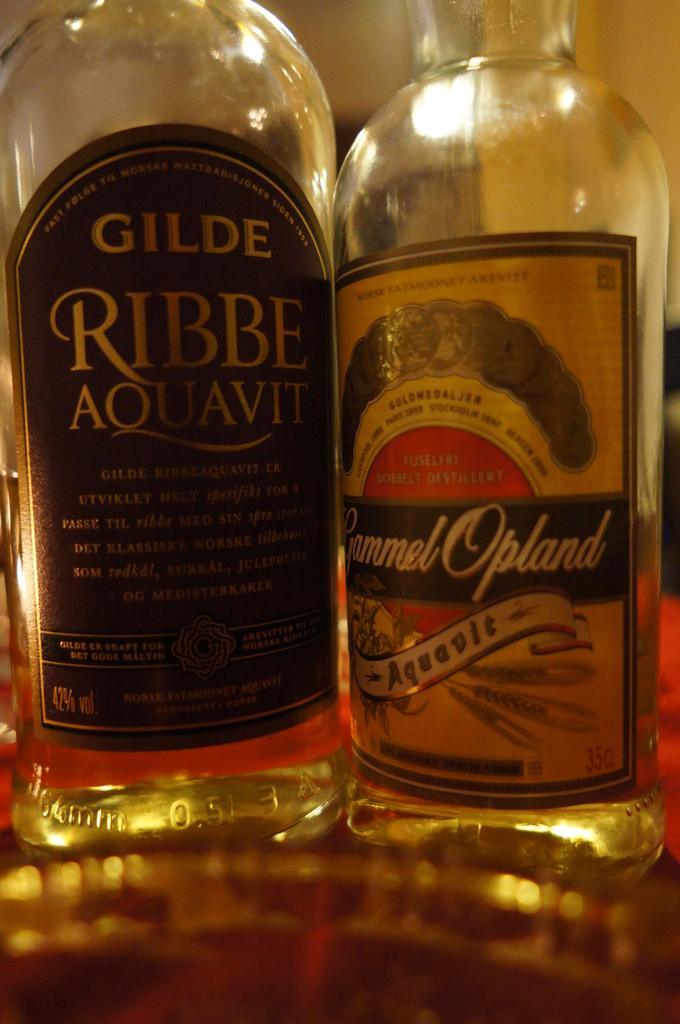How many bottles are visible in the image? There are two bottles in the image. What type of collar can be seen on the umbrella in the image? There is no umbrella or collar present in the image; it only features two bottles. 